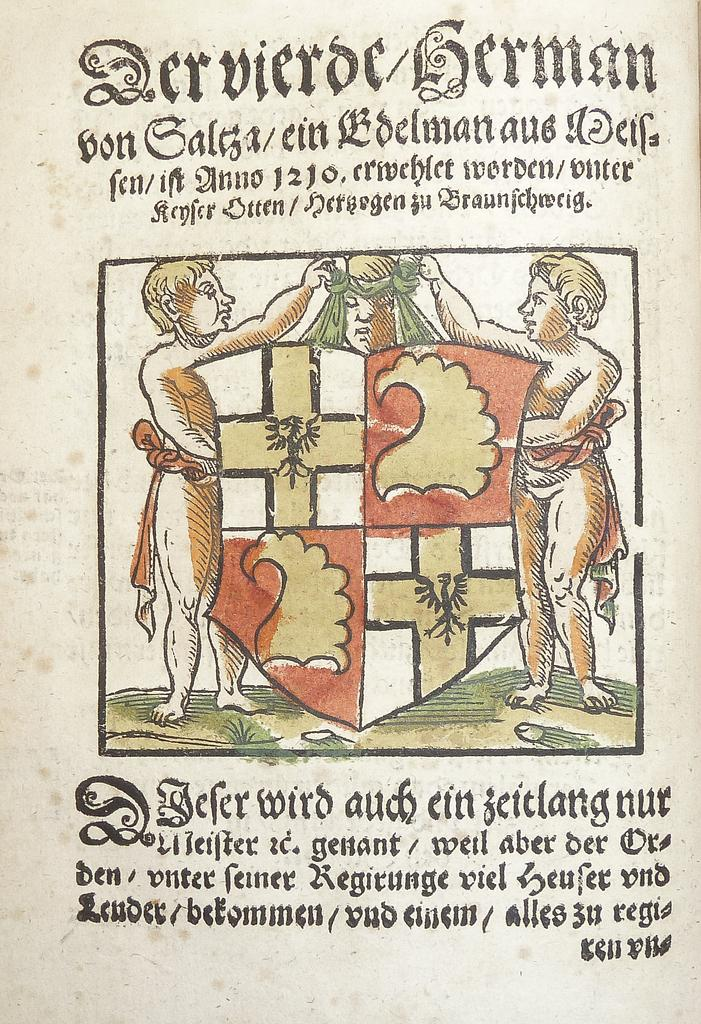What is present in the image that contains both pictures and text? There is a poster in the image that contains both pictures and text. What type of shade is provided by the poster in the image? The poster does not provide any shade, as it is a flat, two-dimensional object. 